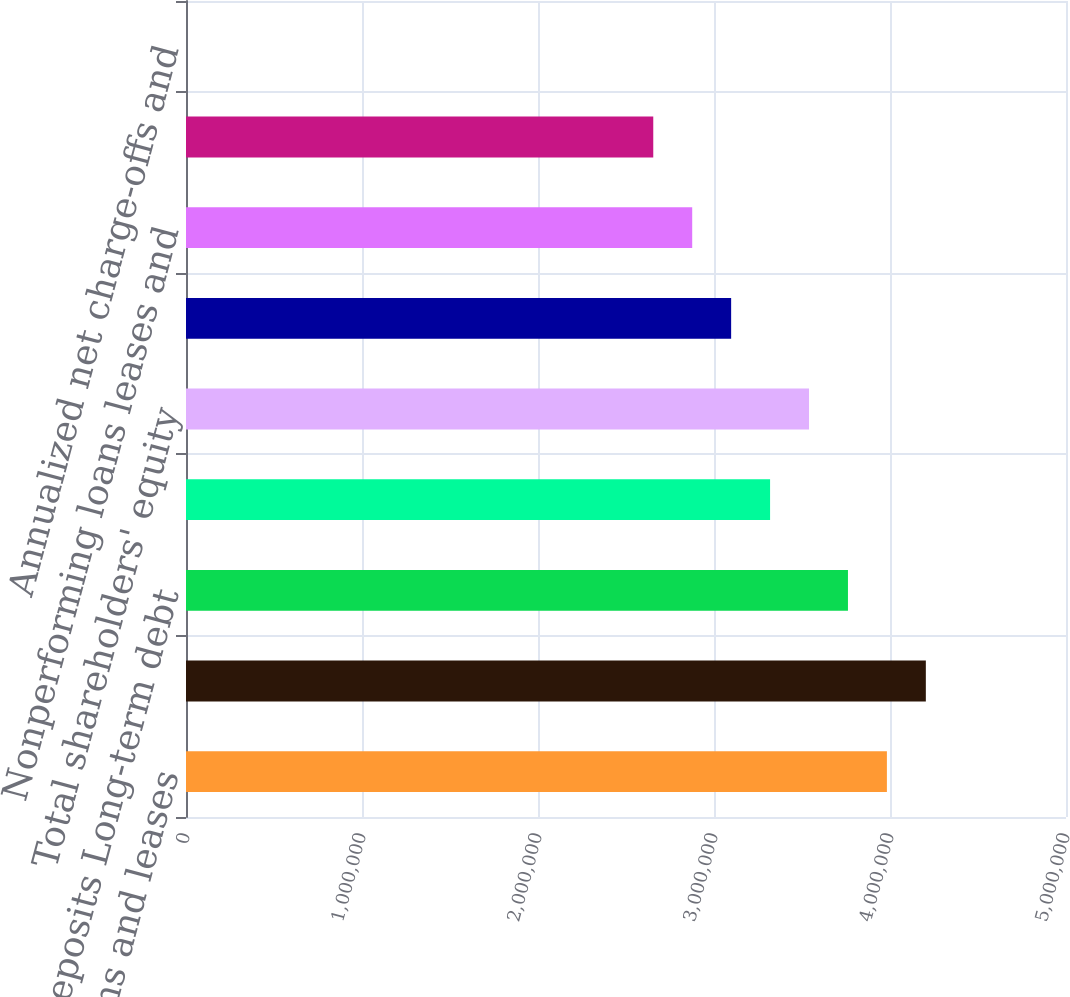<chart> <loc_0><loc_0><loc_500><loc_500><bar_chart><fcel>Total loans and leases<fcel>Total assets<fcel>Total deposits Long-term debt<fcel>Common shareholders' equity<fcel>Total shareholders' equity<fcel>Allowance for credit losses<fcel>Nonperforming loans leases and<fcel>Allowance for loan and lease<fcel>Annualized net charge-offs and<nl><fcel>3.98237e+06<fcel>4.20362e+06<fcel>3.76113e+06<fcel>3.31864e+06<fcel>3.53989e+06<fcel>3.0974e+06<fcel>2.87616e+06<fcel>2.65492e+06<fcel>1.52<nl></chart> 